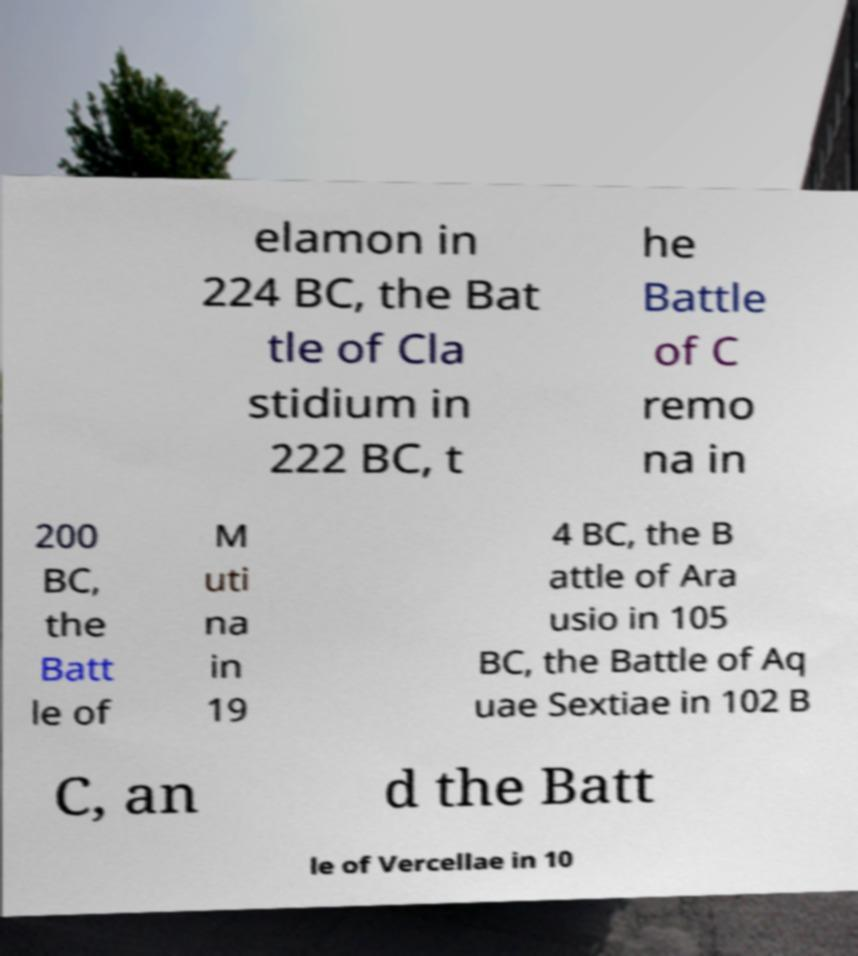Please identify and transcribe the text found in this image. elamon in 224 BC, the Bat tle of Cla stidium in 222 BC, t he Battle of C remo na in 200 BC, the Batt le of M uti na in 19 4 BC, the B attle of Ara usio in 105 BC, the Battle of Aq uae Sextiae in 102 B C, an d the Batt le of Vercellae in 10 